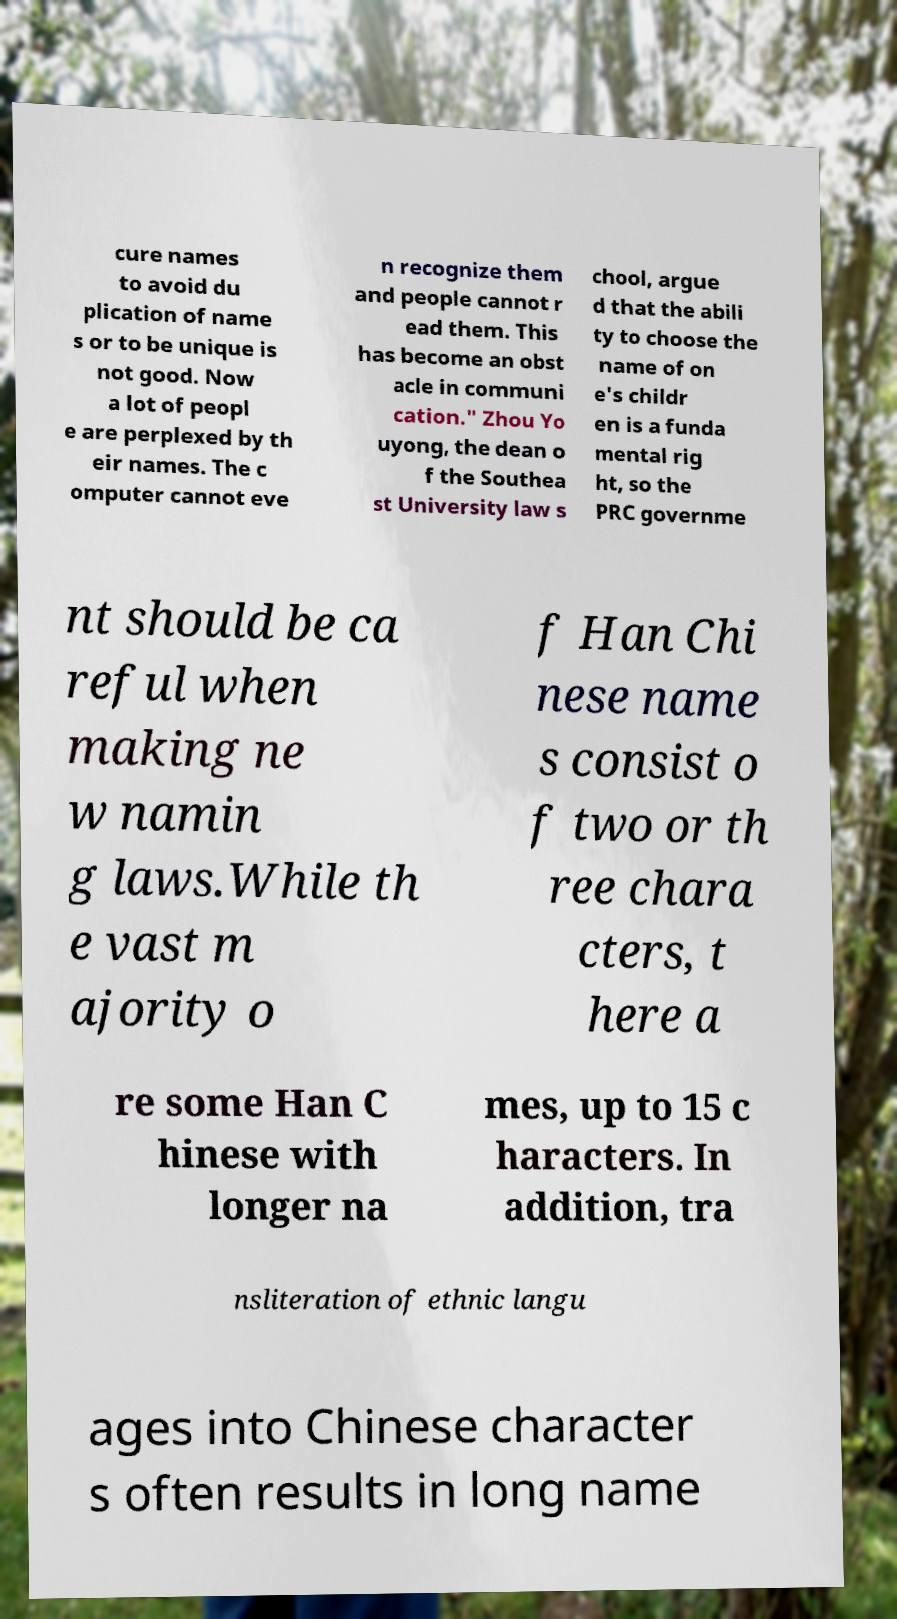Can you accurately transcribe the text from the provided image for me? cure names to avoid du plication of name s or to be unique is not good. Now a lot of peopl e are perplexed by th eir names. The c omputer cannot eve n recognize them and people cannot r ead them. This has become an obst acle in communi cation." Zhou Yo uyong, the dean o f the Southea st University law s chool, argue d that the abili ty to choose the name of on e's childr en is a funda mental rig ht, so the PRC governme nt should be ca reful when making ne w namin g laws.While th e vast m ajority o f Han Chi nese name s consist o f two or th ree chara cters, t here a re some Han C hinese with longer na mes, up to 15 c haracters. In addition, tra nsliteration of ethnic langu ages into Chinese character s often results in long name 